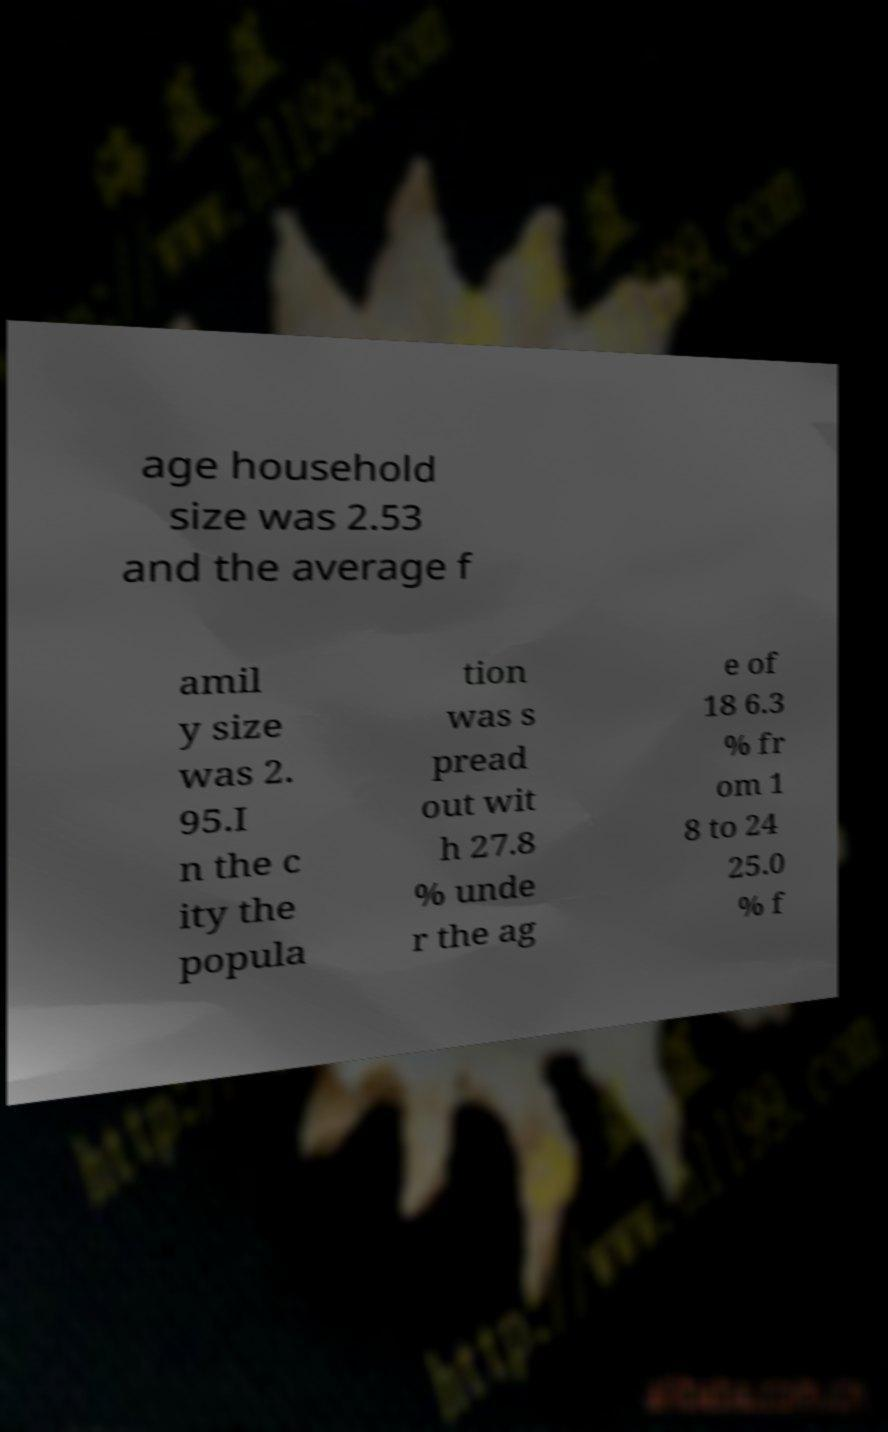Could you assist in decoding the text presented in this image and type it out clearly? age household size was 2.53 and the average f amil y size was 2. 95.I n the c ity the popula tion was s pread out wit h 27.8 % unde r the ag e of 18 6.3 % fr om 1 8 to 24 25.0 % f 